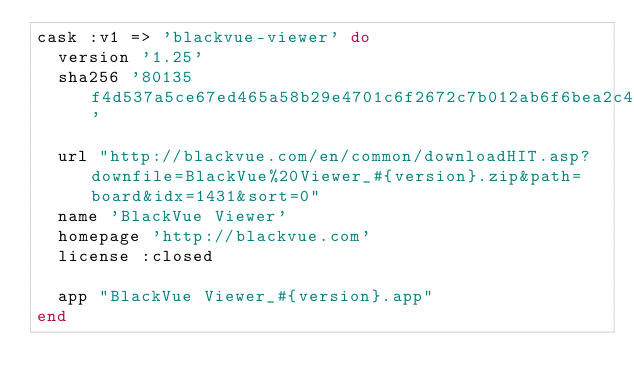Convert code to text. <code><loc_0><loc_0><loc_500><loc_500><_Ruby_>cask :v1 => 'blackvue-viewer' do
  version '1.25'
  sha256 '80135f4d537a5ce67ed465a58b29e4701c6f2672c7b012ab6f6bea2c4d884fcc'

  url "http://blackvue.com/en/common/downloadHIT.asp?downfile=BlackVue%20Viewer_#{version}.zip&path=board&idx=1431&sort=0"
  name 'BlackVue Viewer'
  homepage 'http://blackvue.com'
  license :closed

  app "BlackVue Viewer_#{version}.app"
end
</code> 